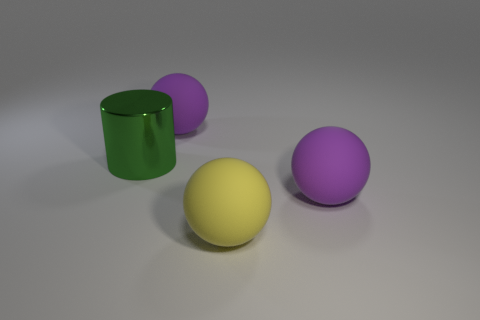What is the shape of the metal thing? cylinder 